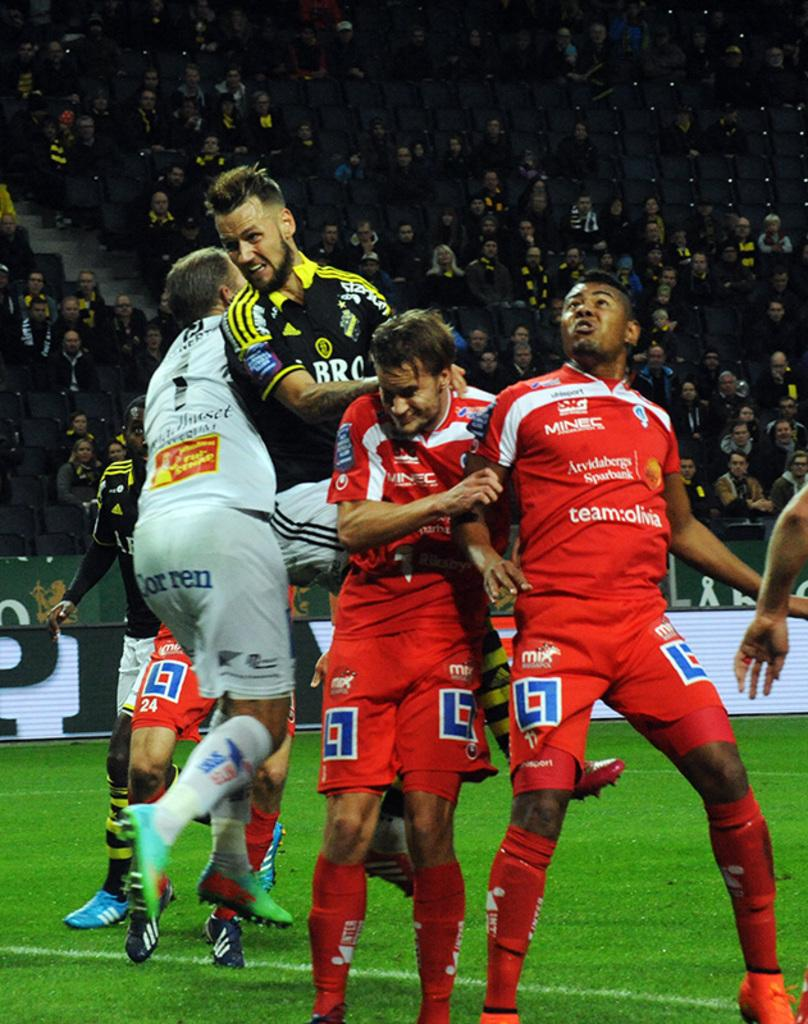<image>
Offer a succinct explanation of the picture presented. Two players with red uniforms that have team:olivia on them go head to head against the opposing team. 